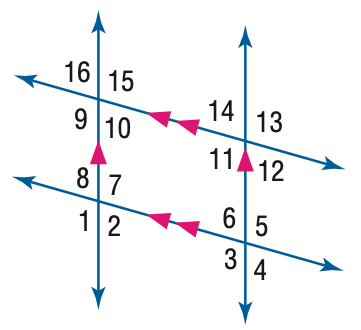Answer the mathemtical geometry problem and directly provide the correct option letter.
Question: In the figure, m \angle 1 = 123. Find the measure of \angle 11.
Choices: A: 57 B: 67 C: 113 D: 123 D 